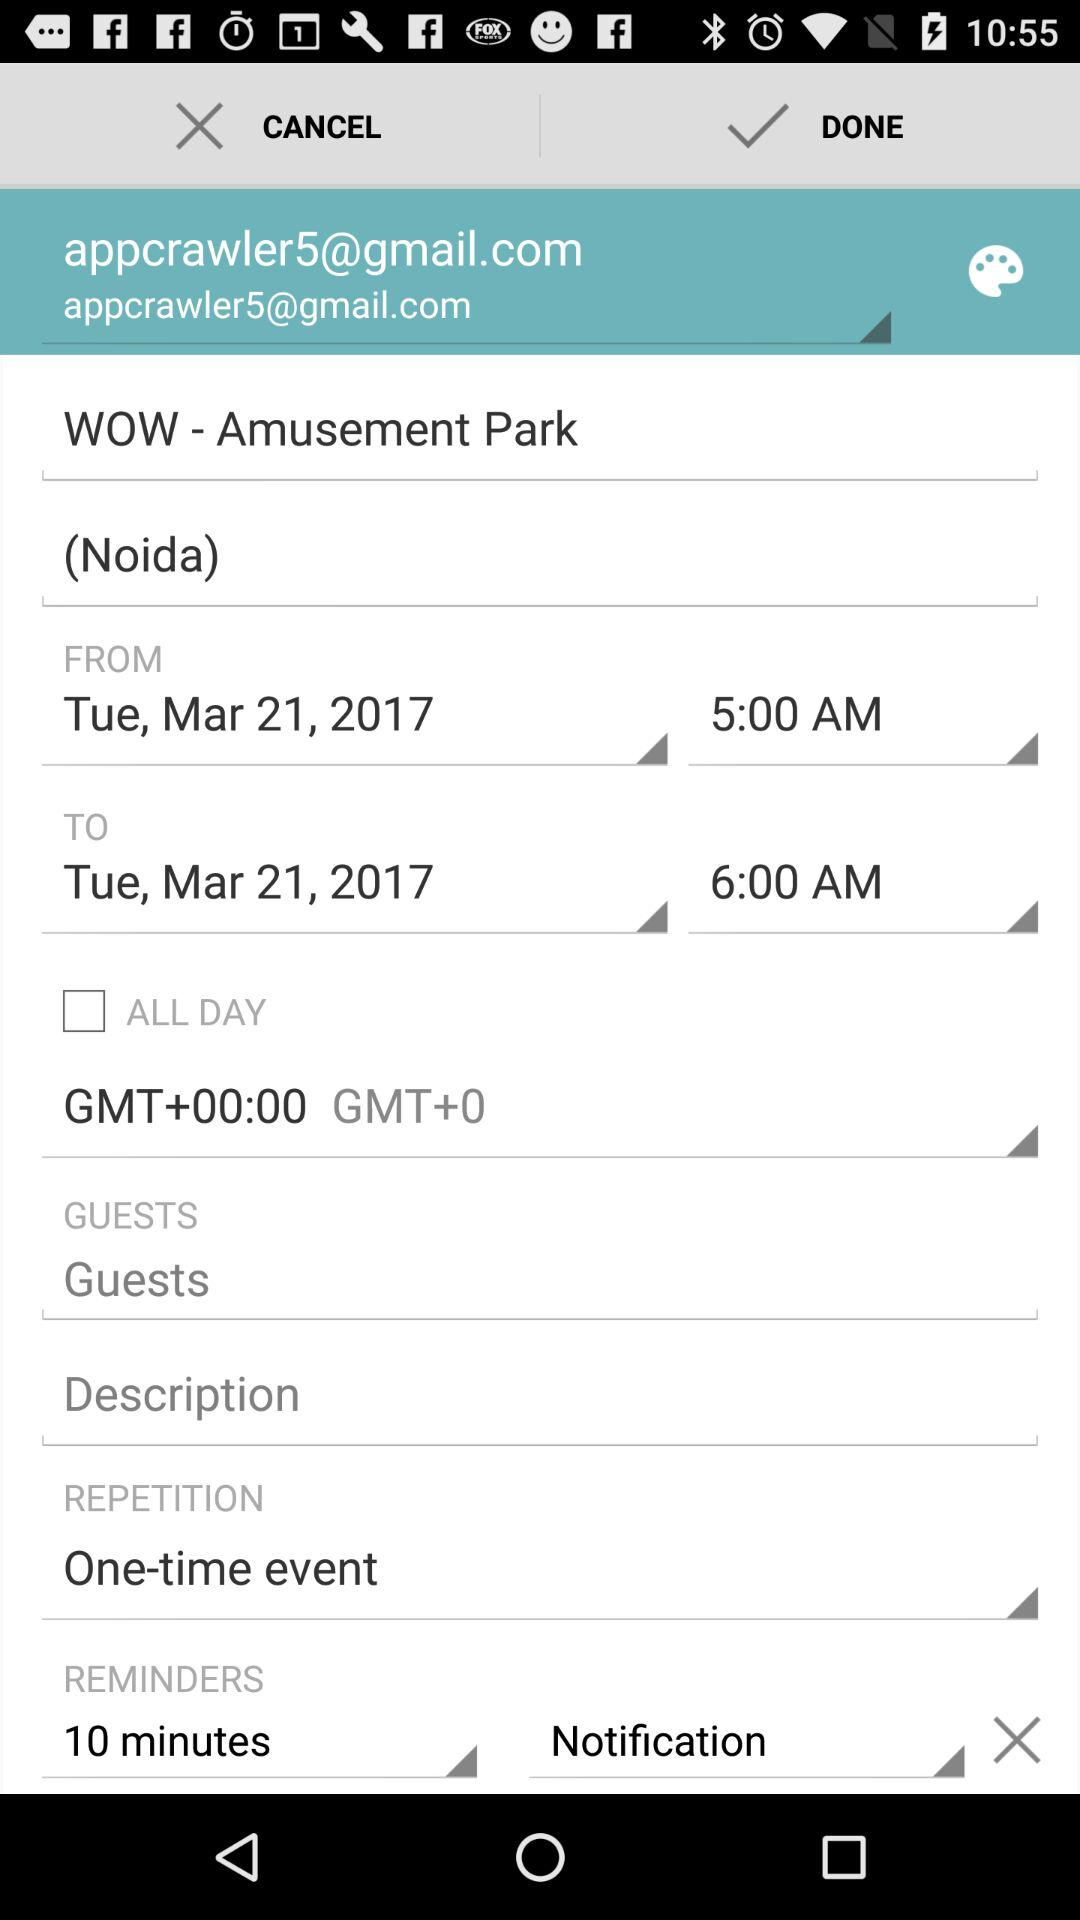How many minutes before the event should a reminder be sent?
Answer the question using a single word or phrase. 10 minutes 